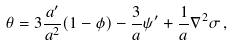<formula> <loc_0><loc_0><loc_500><loc_500>\theta = 3 \frac { a ^ { \prime } } { a ^ { 2 } } ( 1 - \phi ) - \frac { 3 } { a } \psi ^ { \prime } + \frac { 1 } { a } \nabla ^ { 2 } \sigma \, ,</formula> 